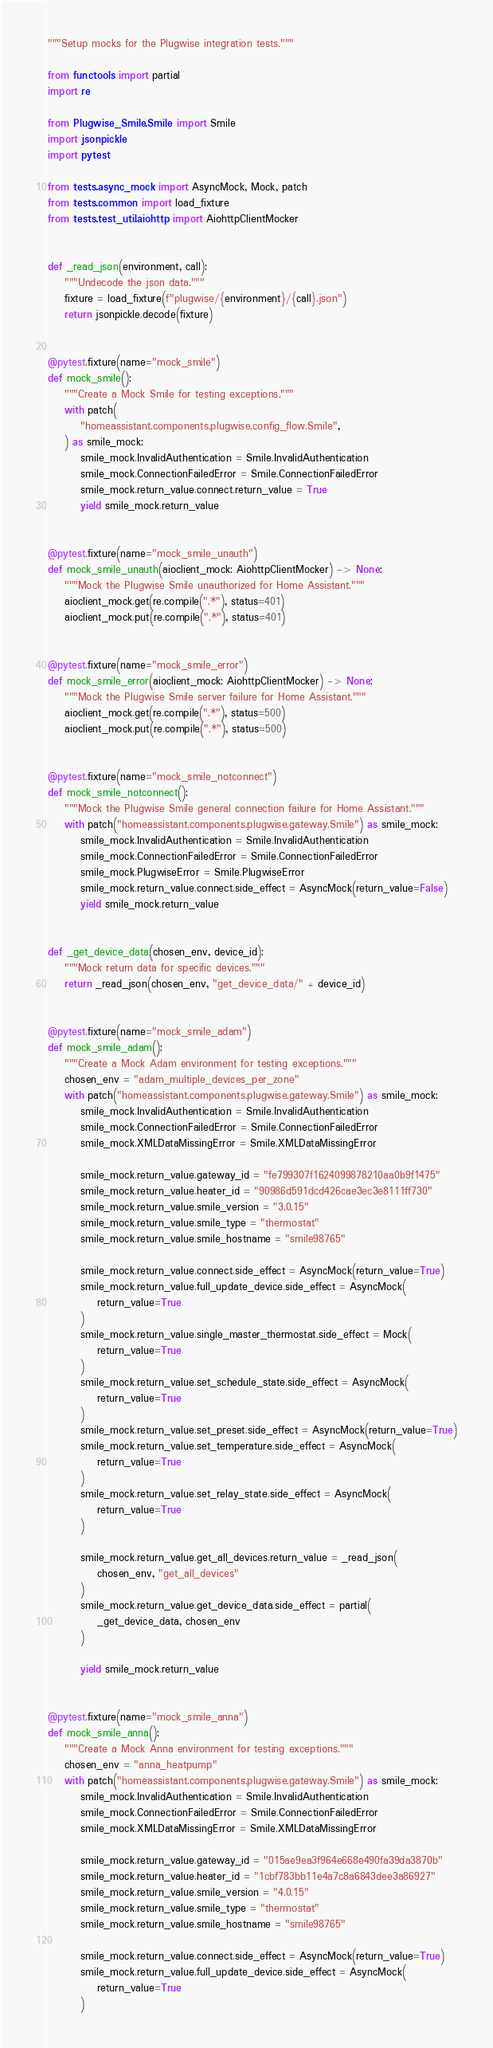Convert code to text. <code><loc_0><loc_0><loc_500><loc_500><_Python_>"""Setup mocks for the Plugwise integration tests."""

from functools import partial
import re

from Plugwise_Smile.Smile import Smile
import jsonpickle
import pytest

from tests.async_mock import AsyncMock, Mock, patch
from tests.common import load_fixture
from tests.test_util.aiohttp import AiohttpClientMocker


def _read_json(environment, call):
    """Undecode the json data."""
    fixture = load_fixture(f"plugwise/{environment}/{call}.json")
    return jsonpickle.decode(fixture)


@pytest.fixture(name="mock_smile")
def mock_smile():
    """Create a Mock Smile for testing exceptions."""
    with patch(
        "homeassistant.components.plugwise.config_flow.Smile",
    ) as smile_mock:
        smile_mock.InvalidAuthentication = Smile.InvalidAuthentication
        smile_mock.ConnectionFailedError = Smile.ConnectionFailedError
        smile_mock.return_value.connect.return_value = True
        yield smile_mock.return_value


@pytest.fixture(name="mock_smile_unauth")
def mock_smile_unauth(aioclient_mock: AiohttpClientMocker) -> None:
    """Mock the Plugwise Smile unauthorized for Home Assistant."""
    aioclient_mock.get(re.compile(".*"), status=401)
    aioclient_mock.put(re.compile(".*"), status=401)


@pytest.fixture(name="mock_smile_error")
def mock_smile_error(aioclient_mock: AiohttpClientMocker) -> None:
    """Mock the Plugwise Smile server failure for Home Assistant."""
    aioclient_mock.get(re.compile(".*"), status=500)
    aioclient_mock.put(re.compile(".*"), status=500)


@pytest.fixture(name="mock_smile_notconnect")
def mock_smile_notconnect():
    """Mock the Plugwise Smile general connection failure for Home Assistant."""
    with patch("homeassistant.components.plugwise.gateway.Smile") as smile_mock:
        smile_mock.InvalidAuthentication = Smile.InvalidAuthentication
        smile_mock.ConnectionFailedError = Smile.ConnectionFailedError
        smile_mock.PlugwiseError = Smile.PlugwiseError
        smile_mock.return_value.connect.side_effect = AsyncMock(return_value=False)
        yield smile_mock.return_value


def _get_device_data(chosen_env, device_id):
    """Mock return data for specific devices."""
    return _read_json(chosen_env, "get_device_data/" + device_id)


@pytest.fixture(name="mock_smile_adam")
def mock_smile_adam():
    """Create a Mock Adam environment for testing exceptions."""
    chosen_env = "adam_multiple_devices_per_zone"
    with patch("homeassistant.components.plugwise.gateway.Smile") as smile_mock:
        smile_mock.InvalidAuthentication = Smile.InvalidAuthentication
        smile_mock.ConnectionFailedError = Smile.ConnectionFailedError
        smile_mock.XMLDataMissingError = Smile.XMLDataMissingError

        smile_mock.return_value.gateway_id = "fe799307f1624099878210aa0b9f1475"
        smile_mock.return_value.heater_id = "90986d591dcd426cae3ec3e8111ff730"
        smile_mock.return_value.smile_version = "3.0.15"
        smile_mock.return_value.smile_type = "thermostat"
        smile_mock.return_value.smile_hostname = "smile98765"

        smile_mock.return_value.connect.side_effect = AsyncMock(return_value=True)
        smile_mock.return_value.full_update_device.side_effect = AsyncMock(
            return_value=True
        )
        smile_mock.return_value.single_master_thermostat.side_effect = Mock(
            return_value=True
        )
        smile_mock.return_value.set_schedule_state.side_effect = AsyncMock(
            return_value=True
        )
        smile_mock.return_value.set_preset.side_effect = AsyncMock(return_value=True)
        smile_mock.return_value.set_temperature.side_effect = AsyncMock(
            return_value=True
        )
        smile_mock.return_value.set_relay_state.side_effect = AsyncMock(
            return_value=True
        )

        smile_mock.return_value.get_all_devices.return_value = _read_json(
            chosen_env, "get_all_devices"
        )
        smile_mock.return_value.get_device_data.side_effect = partial(
            _get_device_data, chosen_env
        )

        yield smile_mock.return_value


@pytest.fixture(name="mock_smile_anna")
def mock_smile_anna():
    """Create a Mock Anna environment for testing exceptions."""
    chosen_env = "anna_heatpump"
    with patch("homeassistant.components.plugwise.gateway.Smile") as smile_mock:
        smile_mock.InvalidAuthentication = Smile.InvalidAuthentication
        smile_mock.ConnectionFailedError = Smile.ConnectionFailedError
        smile_mock.XMLDataMissingError = Smile.XMLDataMissingError

        smile_mock.return_value.gateway_id = "015ae9ea3f964e668e490fa39da3870b"
        smile_mock.return_value.heater_id = "1cbf783bb11e4a7c8a6843dee3a86927"
        smile_mock.return_value.smile_version = "4.0.15"
        smile_mock.return_value.smile_type = "thermostat"
        smile_mock.return_value.smile_hostname = "smile98765"

        smile_mock.return_value.connect.side_effect = AsyncMock(return_value=True)
        smile_mock.return_value.full_update_device.side_effect = AsyncMock(
            return_value=True
        )</code> 